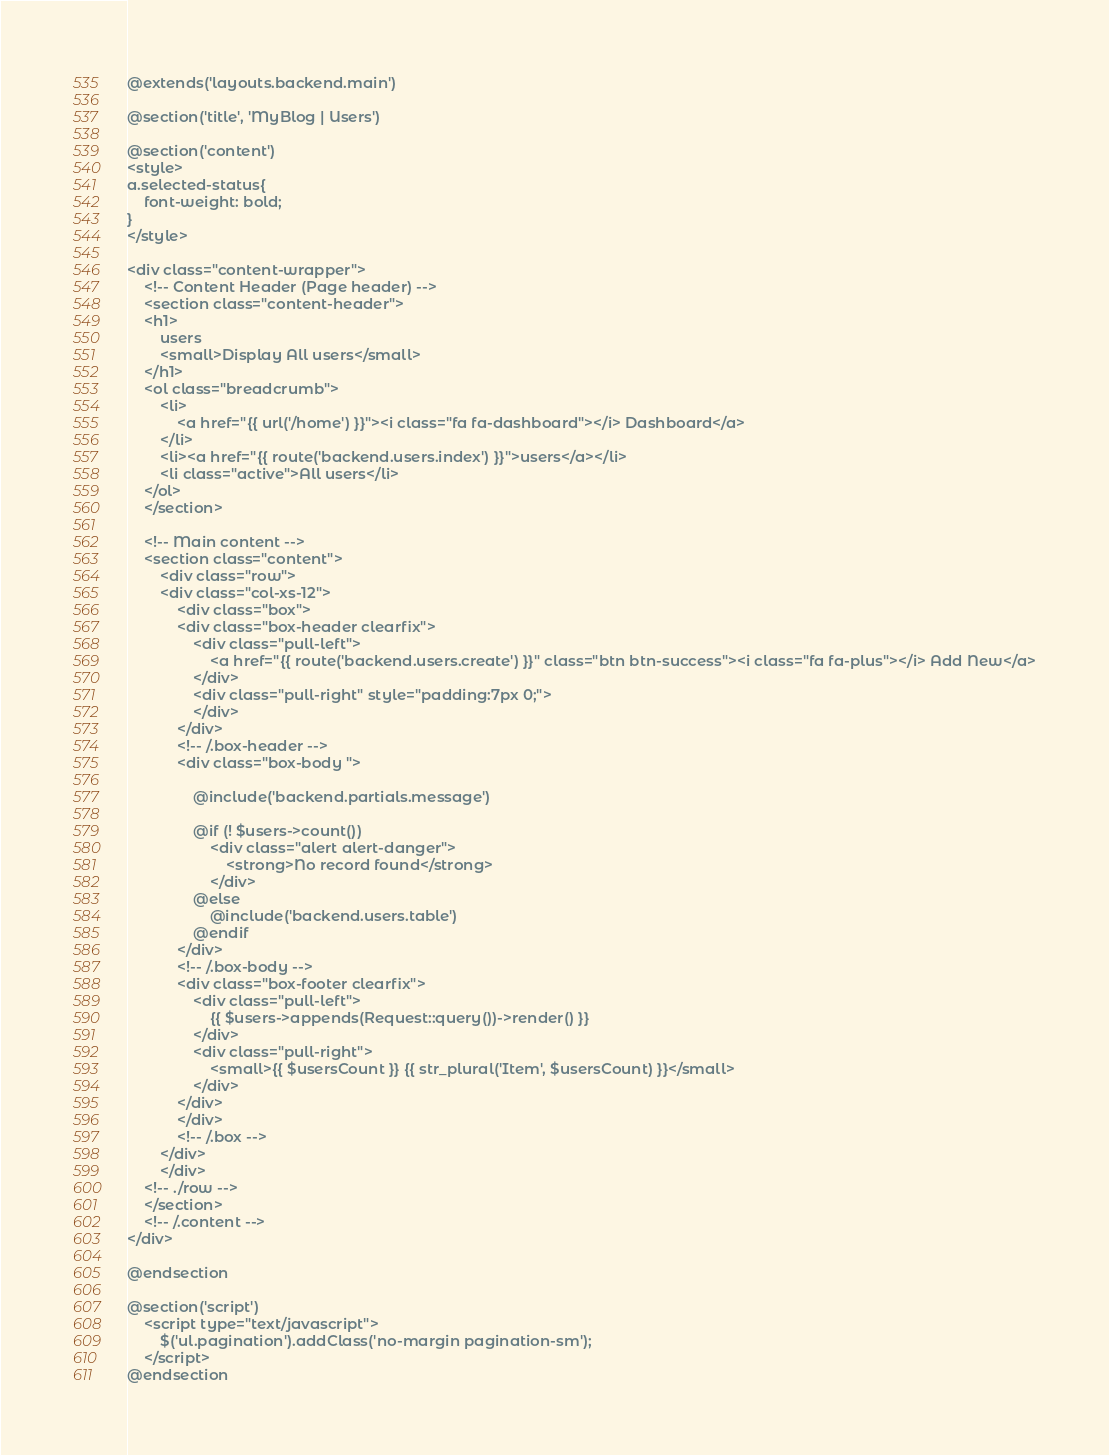Convert code to text. <code><loc_0><loc_0><loc_500><loc_500><_PHP_>@extends('layouts.backend.main')

@section('title', 'MyBlog | Users')

@section('content')
<style>
a.selected-status{
    font-weight: bold;
}
</style>

<div class="content-wrapper">
    <!-- Content Header (Page header) -->
    <section class="content-header">
    <h1>
        users
        <small>Display All users</small>
    </h1>
    <ol class="breadcrumb">
        <li>
            <a href="{{ url('/home') }}"><i class="fa fa-dashboard"></i> Dashboard</a>
        </li>
        <li><a href="{{ route('backend.users.index') }}">users</a></li>
        <li class="active">All users</li>
    </ol>
    </section>

    <!-- Main content -->
    <section class="content">
        <div class="row">
        <div class="col-xs-12">
            <div class="box">
            <div class="box-header clearfix">
                <div class="pull-left">
                    <a href="{{ route('backend.users.create') }}" class="btn btn-success"><i class="fa fa-plus"></i> Add New</a>
                </div>
                <div class="pull-right" style="padding:7px 0;">   
                </div>
            </div>
            <!-- /.box-header -->
            <div class="box-body ">
                
                @include('backend.partials.message')

                @if (! $users->count())
                    <div class="alert alert-danger">
                        <strong>No record found</strong>
                    </div>
                @else
                    @include('backend.users.table')                    
                @endif
            </div>
            <!-- /.box-body -->
            <div class="box-footer clearfix">
                <div class="pull-left">
                    {{ $users->appends(Request::query())->render() }}
                </div>
                <div class="pull-right">
                    <small>{{ $usersCount }} {{ str_plural('Item', $usersCount) }}</small>
                </div>
            </div>
            </div>
            <!-- /.box -->
        </div>
        </div>
    <!-- ./row -->
    </section>
    <!-- /.content -->
</div>

@endsection

@section('script')
    <script type="text/javascript">
        $('ul.pagination').addClass('no-margin pagination-sm');
    </script>
@endsection
</code> 